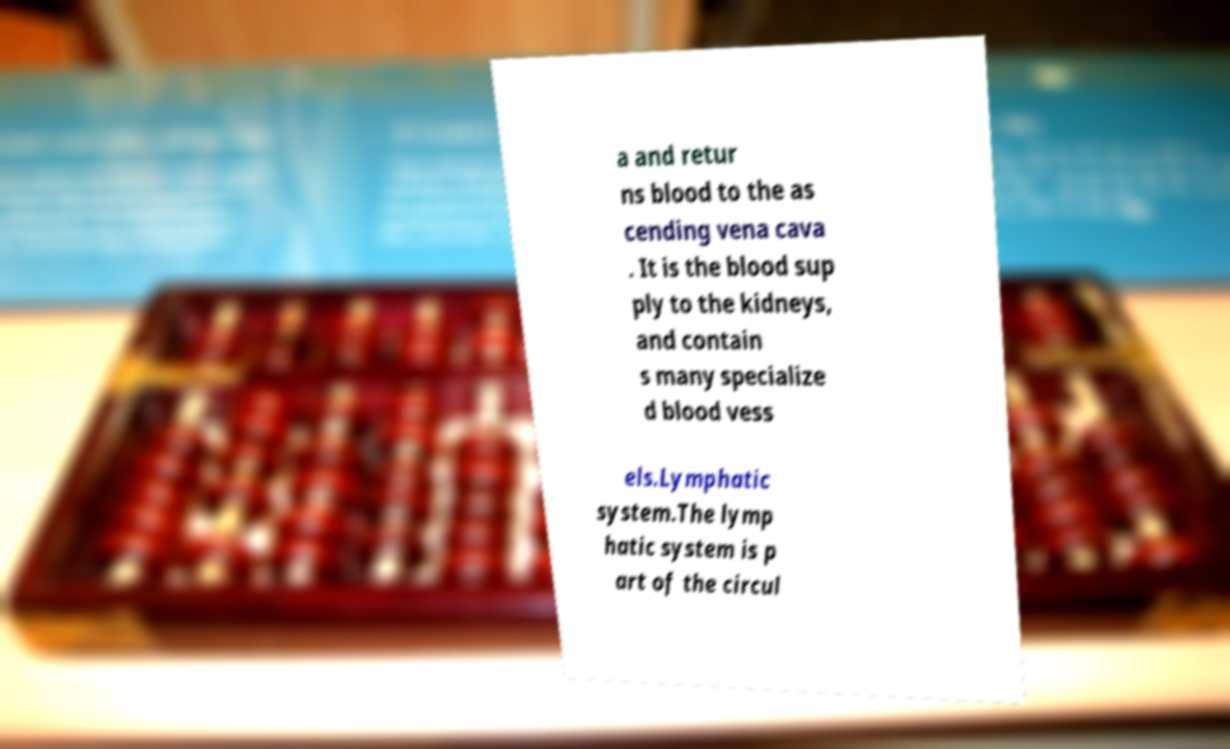I need the written content from this picture converted into text. Can you do that? a and retur ns blood to the as cending vena cava . It is the blood sup ply to the kidneys, and contain s many specialize d blood vess els.Lymphatic system.The lymp hatic system is p art of the circul 